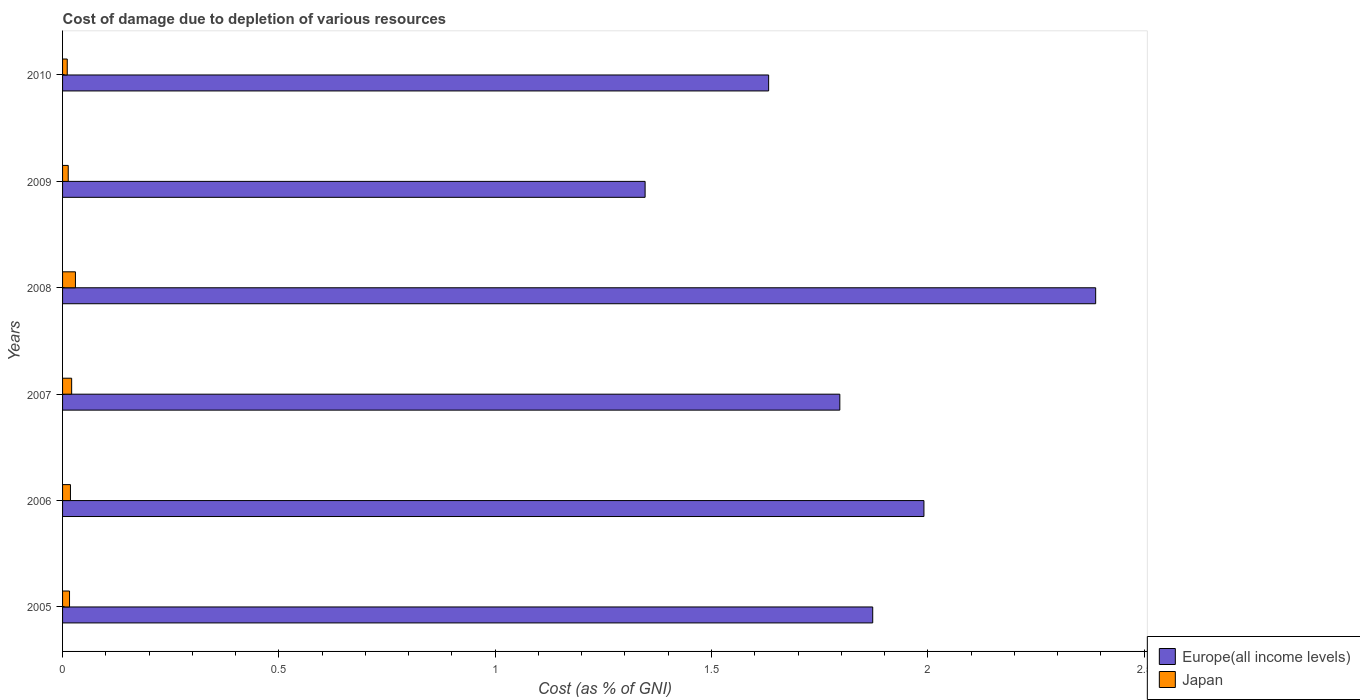How many different coloured bars are there?
Ensure brevity in your answer.  2. Are the number of bars per tick equal to the number of legend labels?
Your answer should be compact. Yes. Are the number of bars on each tick of the Y-axis equal?
Make the answer very short. Yes. How many bars are there on the 1st tick from the top?
Provide a succinct answer. 2. What is the label of the 6th group of bars from the top?
Offer a terse response. 2005. In how many cases, is the number of bars for a given year not equal to the number of legend labels?
Your response must be concise. 0. What is the cost of damage caused due to the depletion of various resources in Europe(all income levels) in 2008?
Your answer should be compact. 2.39. Across all years, what is the maximum cost of damage caused due to the depletion of various resources in Japan?
Ensure brevity in your answer.  0.03. Across all years, what is the minimum cost of damage caused due to the depletion of various resources in Europe(all income levels)?
Your answer should be compact. 1.35. What is the total cost of damage caused due to the depletion of various resources in Japan in the graph?
Your answer should be very brief. 0.11. What is the difference between the cost of damage caused due to the depletion of various resources in Japan in 2007 and that in 2008?
Give a very brief answer. -0.01. What is the difference between the cost of damage caused due to the depletion of various resources in Japan in 2005 and the cost of damage caused due to the depletion of various resources in Europe(all income levels) in 2009?
Provide a succinct answer. -1.33. What is the average cost of damage caused due to the depletion of various resources in Japan per year?
Ensure brevity in your answer.  0.02. In the year 2007, what is the difference between the cost of damage caused due to the depletion of various resources in Japan and cost of damage caused due to the depletion of various resources in Europe(all income levels)?
Provide a short and direct response. -1.78. What is the ratio of the cost of damage caused due to the depletion of various resources in Europe(all income levels) in 2005 to that in 2010?
Ensure brevity in your answer.  1.15. Is the cost of damage caused due to the depletion of various resources in Europe(all income levels) in 2006 less than that in 2009?
Your answer should be compact. No. What is the difference between the highest and the second highest cost of damage caused due to the depletion of various resources in Japan?
Provide a short and direct response. 0.01. What is the difference between the highest and the lowest cost of damage caused due to the depletion of various resources in Japan?
Your response must be concise. 0.02. What does the 2nd bar from the bottom in 2010 represents?
Offer a very short reply. Japan. What is the difference between two consecutive major ticks on the X-axis?
Ensure brevity in your answer.  0.5. Does the graph contain grids?
Make the answer very short. No. Where does the legend appear in the graph?
Your response must be concise. Bottom right. How are the legend labels stacked?
Offer a terse response. Vertical. What is the title of the graph?
Offer a very short reply. Cost of damage due to depletion of various resources. What is the label or title of the X-axis?
Provide a succinct answer. Cost (as % of GNI). What is the label or title of the Y-axis?
Give a very brief answer. Years. What is the Cost (as % of GNI) of Europe(all income levels) in 2005?
Your answer should be compact. 1.87. What is the Cost (as % of GNI) in Japan in 2005?
Provide a succinct answer. 0.02. What is the Cost (as % of GNI) in Europe(all income levels) in 2006?
Ensure brevity in your answer.  1.99. What is the Cost (as % of GNI) in Japan in 2006?
Make the answer very short. 0.02. What is the Cost (as % of GNI) of Europe(all income levels) in 2007?
Keep it short and to the point. 1.8. What is the Cost (as % of GNI) of Japan in 2007?
Your response must be concise. 0.02. What is the Cost (as % of GNI) in Europe(all income levels) in 2008?
Your response must be concise. 2.39. What is the Cost (as % of GNI) in Japan in 2008?
Provide a succinct answer. 0.03. What is the Cost (as % of GNI) of Europe(all income levels) in 2009?
Your response must be concise. 1.35. What is the Cost (as % of GNI) of Japan in 2009?
Provide a succinct answer. 0.01. What is the Cost (as % of GNI) of Europe(all income levels) in 2010?
Your answer should be very brief. 1.63. What is the Cost (as % of GNI) of Japan in 2010?
Make the answer very short. 0.01. Across all years, what is the maximum Cost (as % of GNI) in Europe(all income levels)?
Offer a terse response. 2.39. Across all years, what is the maximum Cost (as % of GNI) of Japan?
Give a very brief answer. 0.03. Across all years, what is the minimum Cost (as % of GNI) of Europe(all income levels)?
Your response must be concise. 1.35. Across all years, what is the minimum Cost (as % of GNI) in Japan?
Ensure brevity in your answer.  0.01. What is the total Cost (as % of GNI) in Europe(all income levels) in the graph?
Give a very brief answer. 11.03. What is the total Cost (as % of GNI) of Japan in the graph?
Provide a succinct answer. 0.11. What is the difference between the Cost (as % of GNI) of Europe(all income levels) in 2005 and that in 2006?
Make the answer very short. -0.12. What is the difference between the Cost (as % of GNI) of Japan in 2005 and that in 2006?
Make the answer very short. -0. What is the difference between the Cost (as % of GNI) in Europe(all income levels) in 2005 and that in 2007?
Offer a very short reply. 0.08. What is the difference between the Cost (as % of GNI) in Japan in 2005 and that in 2007?
Provide a short and direct response. -0. What is the difference between the Cost (as % of GNI) in Europe(all income levels) in 2005 and that in 2008?
Your response must be concise. -0.52. What is the difference between the Cost (as % of GNI) in Japan in 2005 and that in 2008?
Keep it short and to the point. -0.01. What is the difference between the Cost (as % of GNI) in Europe(all income levels) in 2005 and that in 2009?
Keep it short and to the point. 0.53. What is the difference between the Cost (as % of GNI) in Japan in 2005 and that in 2009?
Provide a succinct answer. 0. What is the difference between the Cost (as % of GNI) in Europe(all income levels) in 2005 and that in 2010?
Your answer should be very brief. 0.24. What is the difference between the Cost (as % of GNI) of Japan in 2005 and that in 2010?
Make the answer very short. 0.01. What is the difference between the Cost (as % of GNI) of Europe(all income levels) in 2006 and that in 2007?
Keep it short and to the point. 0.19. What is the difference between the Cost (as % of GNI) in Japan in 2006 and that in 2007?
Provide a short and direct response. -0. What is the difference between the Cost (as % of GNI) of Europe(all income levels) in 2006 and that in 2008?
Keep it short and to the point. -0.4. What is the difference between the Cost (as % of GNI) in Japan in 2006 and that in 2008?
Provide a short and direct response. -0.01. What is the difference between the Cost (as % of GNI) in Europe(all income levels) in 2006 and that in 2009?
Offer a terse response. 0.64. What is the difference between the Cost (as % of GNI) in Japan in 2006 and that in 2009?
Your response must be concise. 0.01. What is the difference between the Cost (as % of GNI) of Europe(all income levels) in 2006 and that in 2010?
Provide a succinct answer. 0.36. What is the difference between the Cost (as % of GNI) in Japan in 2006 and that in 2010?
Give a very brief answer. 0.01. What is the difference between the Cost (as % of GNI) in Europe(all income levels) in 2007 and that in 2008?
Provide a short and direct response. -0.59. What is the difference between the Cost (as % of GNI) in Japan in 2007 and that in 2008?
Your answer should be very brief. -0.01. What is the difference between the Cost (as % of GNI) in Europe(all income levels) in 2007 and that in 2009?
Provide a short and direct response. 0.45. What is the difference between the Cost (as % of GNI) in Japan in 2007 and that in 2009?
Your answer should be very brief. 0.01. What is the difference between the Cost (as % of GNI) of Europe(all income levels) in 2007 and that in 2010?
Your response must be concise. 0.16. What is the difference between the Cost (as % of GNI) in Japan in 2007 and that in 2010?
Provide a short and direct response. 0.01. What is the difference between the Cost (as % of GNI) in Europe(all income levels) in 2008 and that in 2009?
Offer a terse response. 1.04. What is the difference between the Cost (as % of GNI) in Japan in 2008 and that in 2009?
Offer a very short reply. 0.02. What is the difference between the Cost (as % of GNI) in Europe(all income levels) in 2008 and that in 2010?
Offer a very short reply. 0.76. What is the difference between the Cost (as % of GNI) of Japan in 2008 and that in 2010?
Ensure brevity in your answer.  0.02. What is the difference between the Cost (as % of GNI) of Europe(all income levels) in 2009 and that in 2010?
Your answer should be compact. -0.29. What is the difference between the Cost (as % of GNI) of Japan in 2009 and that in 2010?
Your answer should be very brief. 0. What is the difference between the Cost (as % of GNI) of Europe(all income levels) in 2005 and the Cost (as % of GNI) of Japan in 2006?
Provide a succinct answer. 1.85. What is the difference between the Cost (as % of GNI) in Europe(all income levels) in 2005 and the Cost (as % of GNI) in Japan in 2007?
Make the answer very short. 1.85. What is the difference between the Cost (as % of GNI) in Europe(all income levels) in 2005 and the Cost (as % of GNI) in Japan in 2008?
Your answer should be compact. 1.84. What is the difference between the Cost (as % of GNI) of Europe(all income levels) in 2005 and the Cost (as % of GNI) of Japan in 2009?
Your response must be concise. 1.86. What is the difference between the Cost (as % of GNI) of Europe(all income levels) in 2005 and the Cost (as % of GNI) of Japan in 2010?
Keep it short and to the point. 1.86. What is the difference between the Cost (as % of GNI) of Europe(all income levels) in 2006 and the Cost (as % of GNI) of Japan in 2007?
Offer a terse response. 1.97. What is the difference between the Cost (as % of GNI) in Europe(all income levels) in 2006 and the Cost (as % of GNI) in Japan in 2008?
Make the answer very short. 1.96. What is the difference between the Cost (as % of GNI) in Europe(all income levels) in 2006 and the Cost (as % of GNI) in Japan in 2009?
Provide a succinct answer. 1.98. What is the difference between the Cost (as % of GNI) in Europe(all income levels) in 2006 and the Cost (as % of GNI) in Japan in 2010?
Your answer should be compact. 1.98. What is the difference between the Cost (as % of GNI) of Europe(all income levels) in 2007 and the Cost (as % of GNI) of Japan in 2008?
Ensure brevity in your answer.  1.77. What is the difference between the Cost (as % of GNI) of Europe(all income levels) in 2007 and the Cost (as % of GNI) of Japan in 2009?
Make the answer very short. 1.78. What is the difference between the Cost (as % of GNI) in Europe(all income levels) in 2007 and the Cost (as % of GNI) in Japan in 2010?
Keep it short and to the point. 1.79. What is the difference between the Cost (as % of GNI) of Europe(all income levels) in 2008 and the Cost (as % of GNI) of Japan in 2009?
Make the answer very short. 2.38. What is the difference between the Cost (as % of GNI) in Europe(all income levels) in 2008 and the Cost (as % of GNI) in Japan in 2010?
Keep it short and to the point. 2.38. What is the difference between the Cost (as % of GNI) in Europe(all income levels) in 2009 and the Cost (as % of GNI) in Japan in 2010?
Provide a succinct answer. 1.34. What is the average Cost (as % of GNI) in Europe(all income levels) per year?
Make the answer very short. 1.84. What is the average Cost (as % of GNI) of Japan per year?
Your response must be concise. 0.02. In the year 2005, what is the difference between the Cost (as % of GNI) of Europe(all income levels) and Cost (as % of GNI) of Japan?
Give a very brief answer. 1.86. In the year 2006, what is the difference between the Cost (as % of GNI) in Europe(all income levels) and Cost (as % of GNI) in Japan?
Your response must be concise. 1.97. In the year 2007, what is the difference between the Cost (as % of GNI) of Europe(all income levels) and Cost (as % of GNI) of Japan?
Ensure brevity in your answer.  1.78. In the year 2008, what is the difference between the Cost (as % of GNI) of Europe(all income levels) and Cost (as % of GNI) of Japan?
Provide a short and direct response. 2.36. In the year 2009, what is the difference between the Cost (as % of GNI) in Europe(all income levels) and Cost (as % of GNI) in Japan?
Offer a very short reply. 1.33. In the year 2010, what is the difference between the Cost (as % of GNI) in Europe(all income levels) and Cost (as % of GNI) in Japan?
Keep it short and to the point. 1.62. What is the ratio of the Cost (as % of GNI) of Europe(all income levels) in 2005 to that in 2006?
Ensure brevity in your answer.  0.94. What is the ratio of the Cost (as % of GNI) of Japan in 2005 to that in 2006?
Make the answer very short. 0.88. What is the ratio of the Cost (as % of GNI) in Europe(all income levels) in 2005 to that in 2007?
Keep it short and to the point. 1.04. What is the ratio of the Cost (as % of GNI) in Japan in 2005 to that in 2007?
Provide a succinct answer. 0.77. What is the ratio of the Cost (as % of GNI) of Europe(all income levels) in 2005 to that in 2008?
Provide a succinct answer. 0.78. What is the ratio of the Cost (as % of GNI) of Japan in 2005 to that in 2008?
Your answer should be compact. 0.54. What is the ratio of the Cost (as % of GNI) in Europe(all income levels) in 2005 to that in 2009?
Provide a succinct answer. 1.39. What is the ratio of the Cost (as % of GNI) in Japan in 2005 to that in 2009?
Your answer should be very brief. 1.23. What is the ratio of the Cost (as % of GNI) in Europe(all income levels) in 2005 to that in 2010?
Ensure brevity in your answer.  1.15. What is the ratio of the Cost (as % of GNI) of Japan in 2005 to that in 2010?
Your response must be concise. 1.49. What is the ratio of the Cost (as % of GNI) of Europe(all income levels) in 2006 to that in 2007?
Your answer should be very brief. 1.11. What is the ratio of the Cost (as % of GNI) in Japan in 2006 to that in 2007?
Provide a succinct answer. 0.87. What is the ratio of the Cost (as % of GNI) in Europe(all income levels) in 2006 to that in 2008?
Provide a short and direct response. 0.83. What is the ratio of the Cost (as % of GNI) of Japan in 2006 to that in 2008?
Your answer should be very brief. 0.61. What is the ratio of the Cost (as % of GNI) in Europe(all income levels) in 2006 to that in 2009?
Ensure brevity in your answer.  1.48. What is the ratio of the Cost (as % of GNI) of Japan in 2006 to that in 2009?
Provide a succinct answer. 1.39. What is the ratio of the Cost (as % of GNI) of Europe(all income levels) in 2006 to that in 2010?
Ensure brevity in your answer.  1.22. What is the ratio of the Cost (as % of GNI) of Japan in 2006 to that in 2010?
Provide a succinct answer. 1.68. What is the ratio of the Cost (as % of GNI) in Europe(all income levels) in 2007 to that in 2008?
Offer a very short reply. 0.75. What is the ratio of the Cost (as % of GNI) of Japan in 2007 to that in 2008?
Provide a short and direct response. 0.71. What is the ratio of the Cost (as % of GNI) in Europe(all income levels) in 2007 to that in 2009?
Offer a very short reply. 1.33. What is the ratio of the Cost (as % of GNI) of Japan in 2007 to that in 2009?
Your response must be concise. 1.61. What is the ratio of the Cost (as % of GNI) of Europe(all income levels) in 2007 to that in 2010?
Give a very brief answer. 1.1. What is the ratio of the Cost (as % of GNI) in Japan in 2007 to that in 2010?
Offer a very short reply. 1.94. What is the ratio of the Cost (as % of GNI) of Europe(all income levels) in 2008 to that in 2009?
Keep it short and to the point. 1.77. What is the ratio of the Cost (as % of GNI) of Japan in 2008 to that in 2009?
Provide a short and direct response. 2.27. What is the ratio of the Cost (as % of GNI) of Europe(all income levels) in 2008 to that in 2010?
Your response must be concise. 1.46. What is the ratio of the Cost (as % of GNI) in Japan in 2008 to that in 2010?
Provide a short and direct response. 2.74. What is the ratio of the Cost (as % of GNI) of Europe(all income levels) in 2009 to that in 2010?
Provide a succinct answer. 0.82. What is the ratio of the Cost (as % of GNI) of Japan in 2009 to that in 2010?
Make the answer very short. 1.21. What is the difference between the highest and the second highest Cost (as % of GNI) of Europe(all income levels)?
Make the answer very short. 0.4. What is the difference between the highest and the second highest Cost (as % of GNI) in Japan?
Offer a very short reply. 0.01. What is the difference between the highest and the lowest Cost (as % of GNI) in Europe(all income levels)?
Offer a terse response. 1.04. What is the difference between the highest and the lowest Cost (as % of GNI) in Japan?
Make the answer very short. 0.02. 